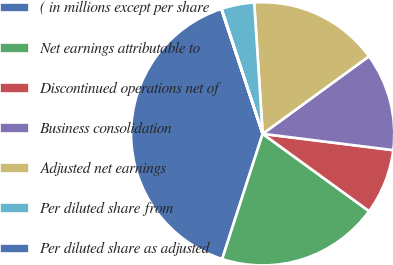Convert chart to OTSL. <chart><loc_0><loc_0><loc_500><loc_500><pie_chart><fcel>( in millions except per share<fcel>Net earnings attributable to<fcel>Discontinued operations net of<fcel>Business consolidation<fcel>Adjusted net earnings<fcel>Per diluted share from<fcel>Per diluted share as adjusted<nl><fcel>39.93%<fcel>19.98%<fcel>8.02%<fcel>12.01%<fcel>16.0%<fcel>4.03%<fcel>0.04%<nl></chart> 